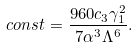Convert formula to latex. <formula><loc_0><loc_0><loc_500><loc_500>c o n s t = \frac { 9 6 0 c _ { 3 } \gamma _ { 1 } ^ { 2 } } { 7 \alpha ^ { 3 } \Lambda ^ { 6 } } .</formula> 